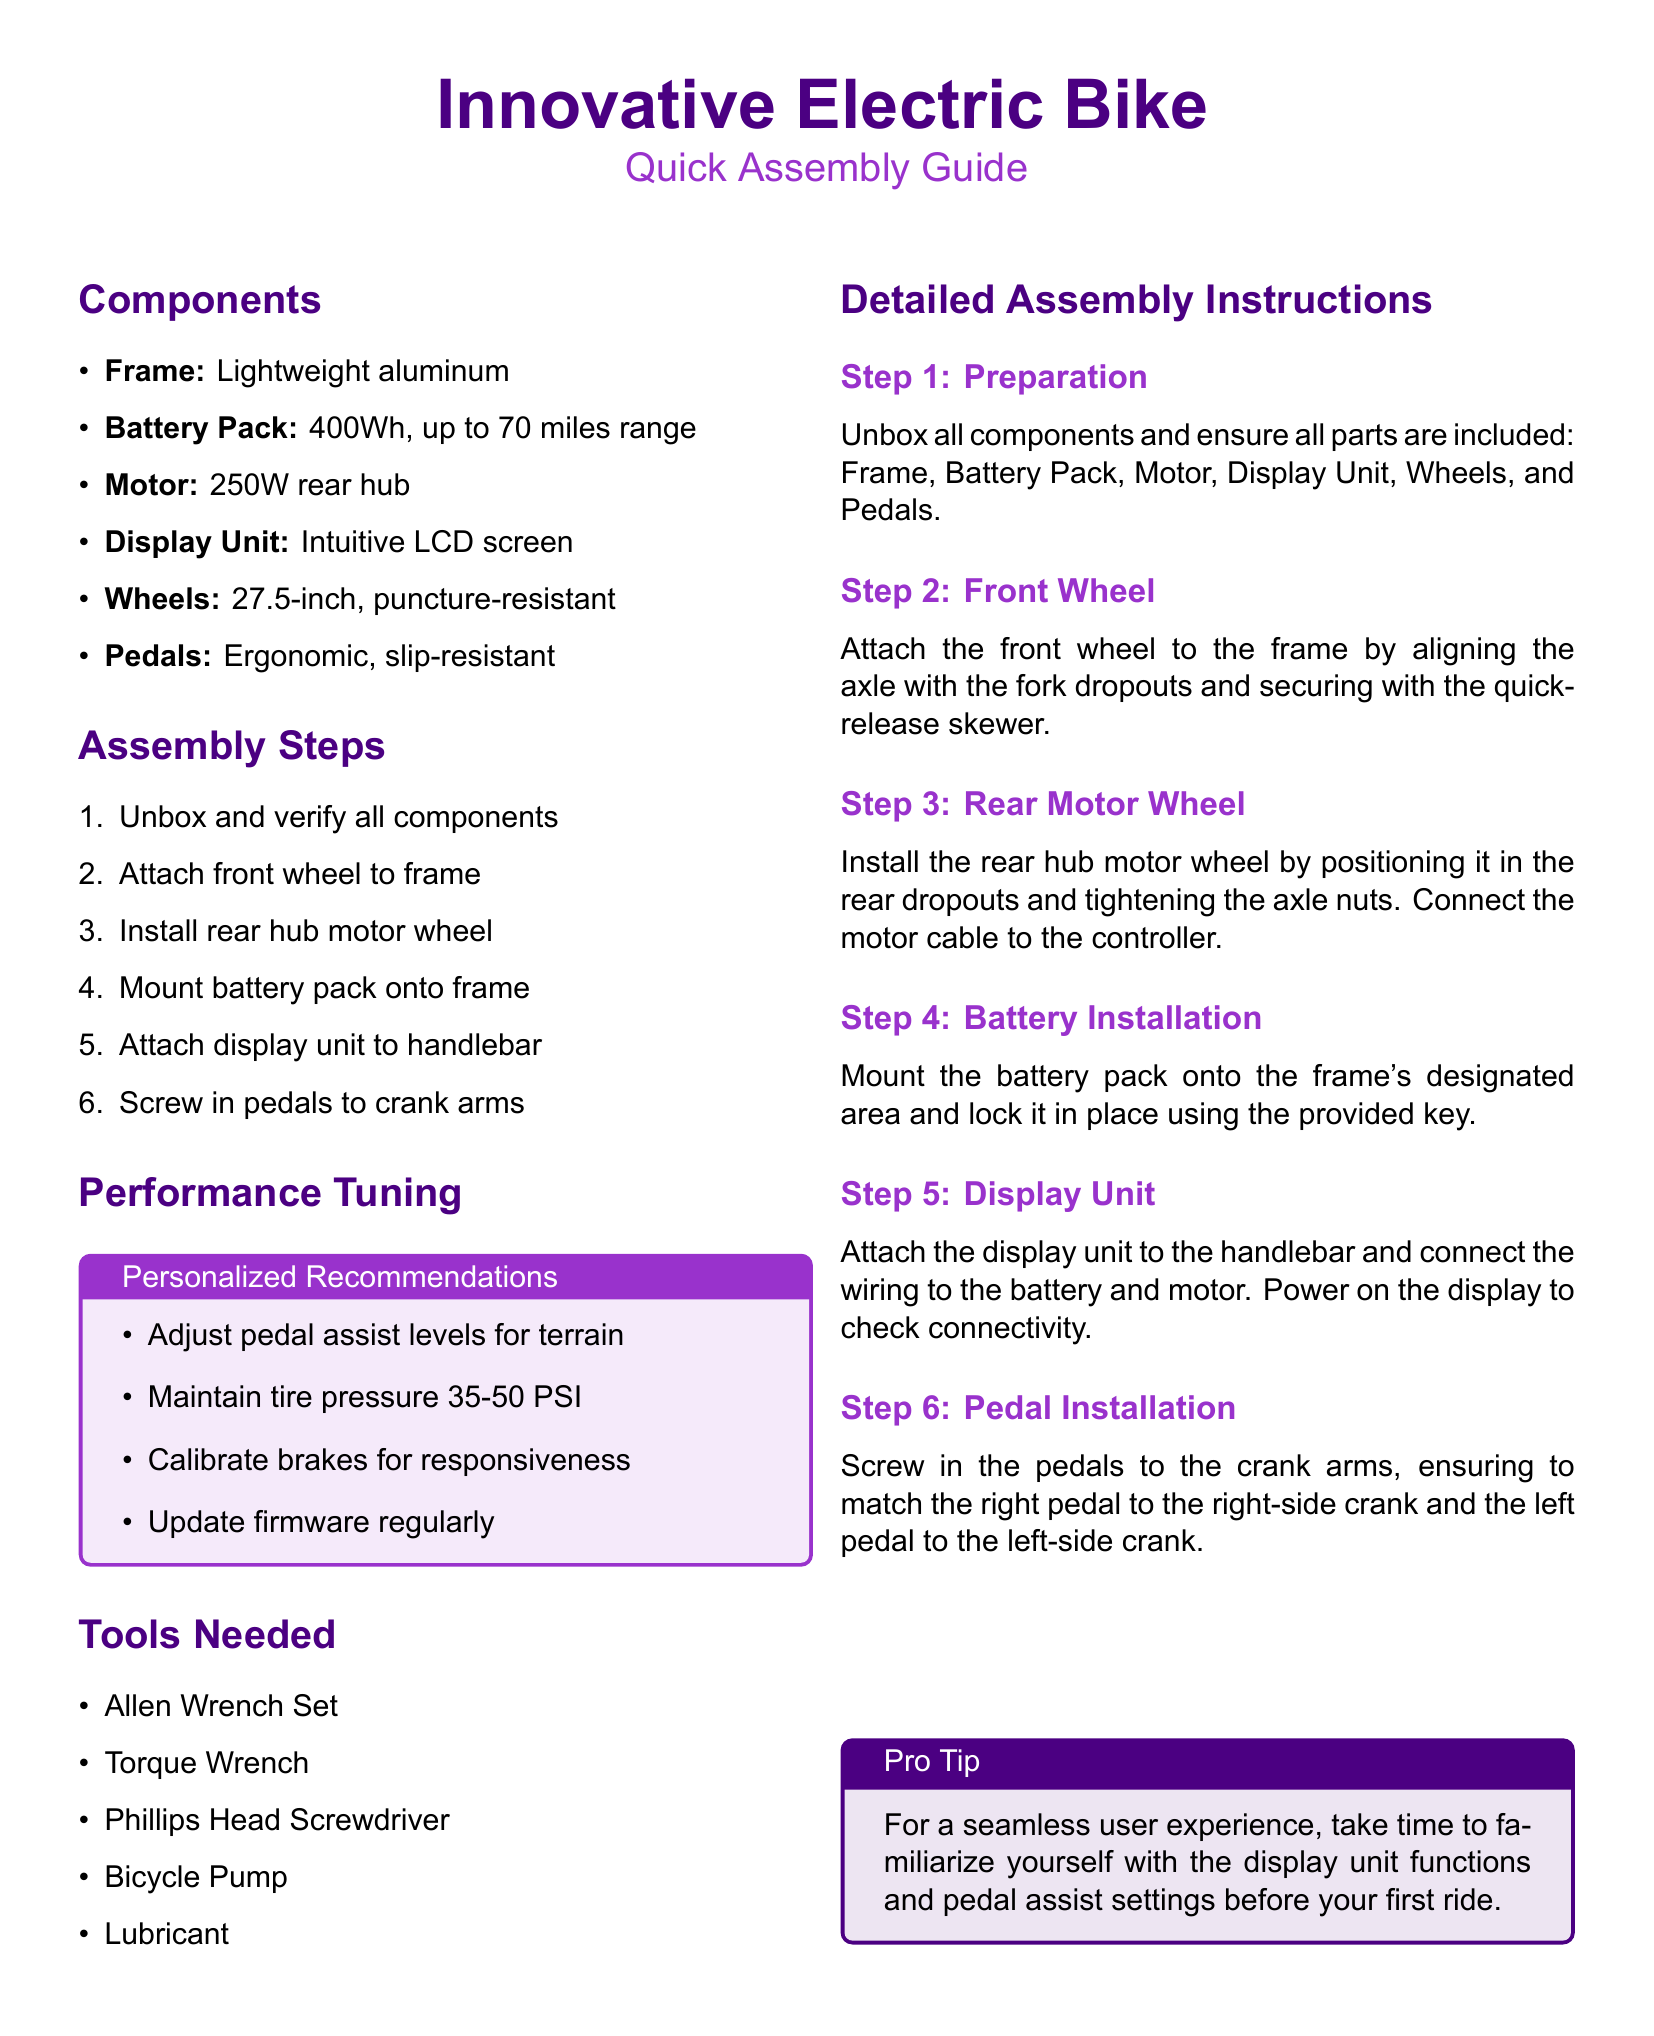What is the battery capacity? The battery capacity is specified in the components section of the document and is 400Wh.
Answer: 400Wh How many assembly steps are there? The total number of assembly steps is mentioned in the assembly steps section, which lists six tasks.
Answer: 6 What type of motor is used? The document specifies the motor type as a 250W rear hub in the components section.
Answer: 250W rear hub What should the tire pressure be? The optimal tire pressure range is provided in the performance tuning section as 35-50 PSI.
Answer: 35-50 PSI What tools are needed for assembly? The list of tools includes an Allen Wrench Set, Torque Wrench, Phillips Head Screwdriver, Bicycle Pump, and Lubricant.
Answer: Allen Wrench Set, Torque Wrench, Phillips Head Screwdriver, Bicycle Pump, Lubricant Which component is mounted to the handlebar? The display unit is indicated to be attached to the handlebar in the assembly steps.
Answer: Display Unit What is a recommended action for a seamless user experience? The pro tip section suggests familiarizing with the display unit functions before the first ride.
Answer: Familiarize with display unit functions What should you do after installing the rear hub motor wheel? After installation, you connect the motor cable to the controller, as detailed in the document.
Answer: Connect motor cable to the controller 